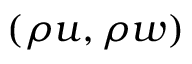Convert formula to latex. <formula><loc_0><loc_0><loc_500><loc_500>( \rho u , \rho w )</formula> 